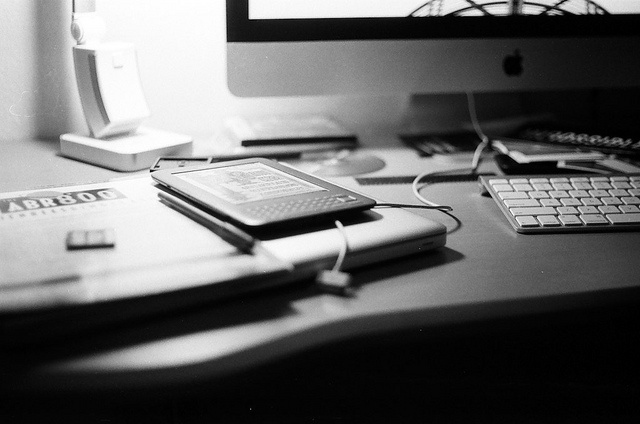Describe the objects in this image and their specific colors. I can see laptop in lightgray, black, darkgray, and gray tones, tv in lightgray, black, darkgray, and gray tones, cell phone in lightgray, darkgray, black, and gray tones, and keyboard in lightgray, darkgray, gray, and black tones in this image. 